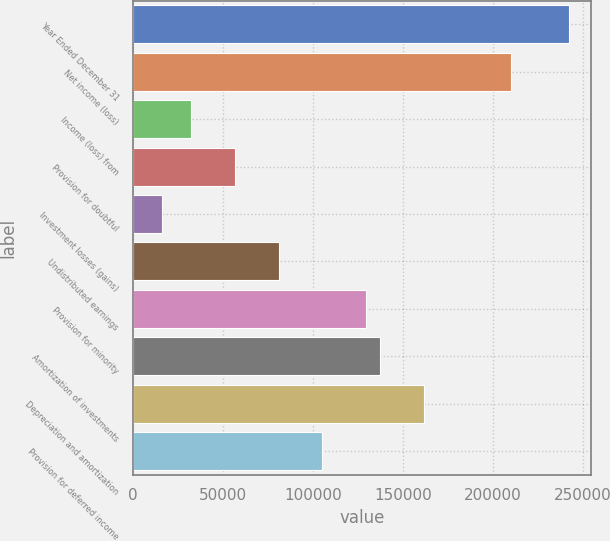<chart> <loc_0><loc_0><loc_500><loc_500><bar_chart><fcel>Year Ended December 31<fcel>Net income (loss)<fcel>Income (loss) from<fcel>Provision for doubtful<fcel>Investment losses (gains)<fcel>Undistributed earnings<fcel>Provision for minority<fcel>Amortization of investments<fcel>Depreciation and amortization<fcel>Provision for deferred income<nl><fcel>242411<fcel>210090<fcel>32323.5<fcel>56564.3<fcel>16162.9<fcel>80805.2<fcel>129287<fcel>137367<fcel>161608<fcel>105046<nl></chart> 